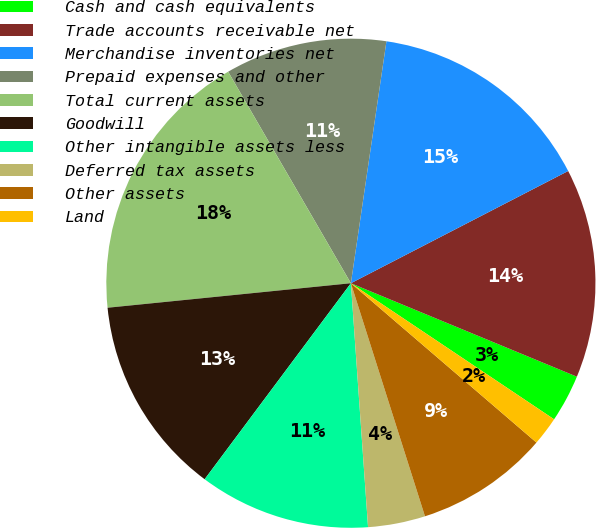<chart> <loc_0><loc_0><loc_500><loc_500><pie_chart><fcel>Cash and cash equivalents<fcel>Trade accounts receivable net<fcel>Merchandise inventories net<fcel>Prepaid expenses and other<fcel>Total current assets<fcel>Goodwill<fcel>Other intangible assets less<fcel>Deferred tax assets<fcel>Other assets<fcel>Land<nl><fcel>3.15%<fcel>13.83%<fcel>15.09%<fcel>10.69%<fcel>18.23%<fcel>13.2%<fcel>11.32%<fcel>3.78%<fcel>8.81%<fcel>1.9%<nl></chart> 